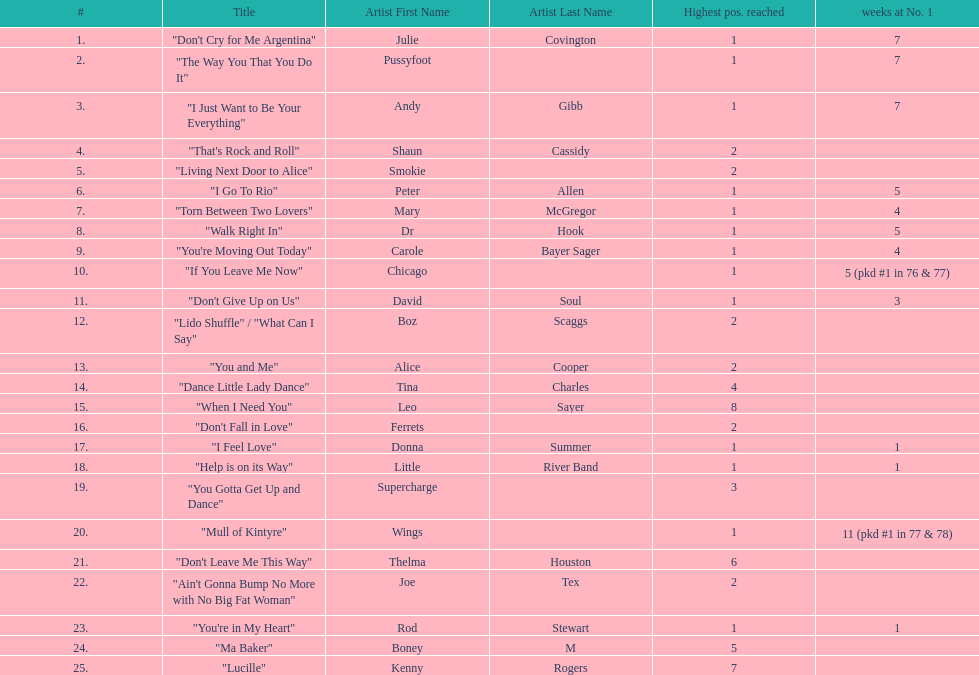What was the number of weeks that julie covington's single " don't cry for me argentinia," was at number 1 in 1977? 7. 